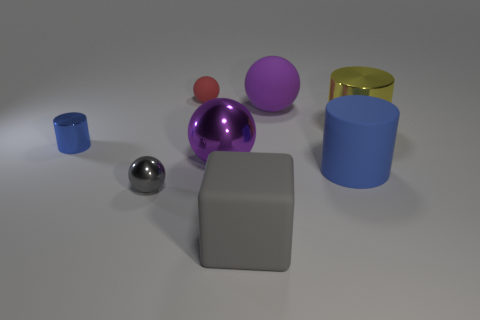Does the small cylinder have the same color as the tiny rubber sphere? No, the small cylinder is blue, while the tiny rubber sphere is red, indicating a clear difference in color between the two objects. 